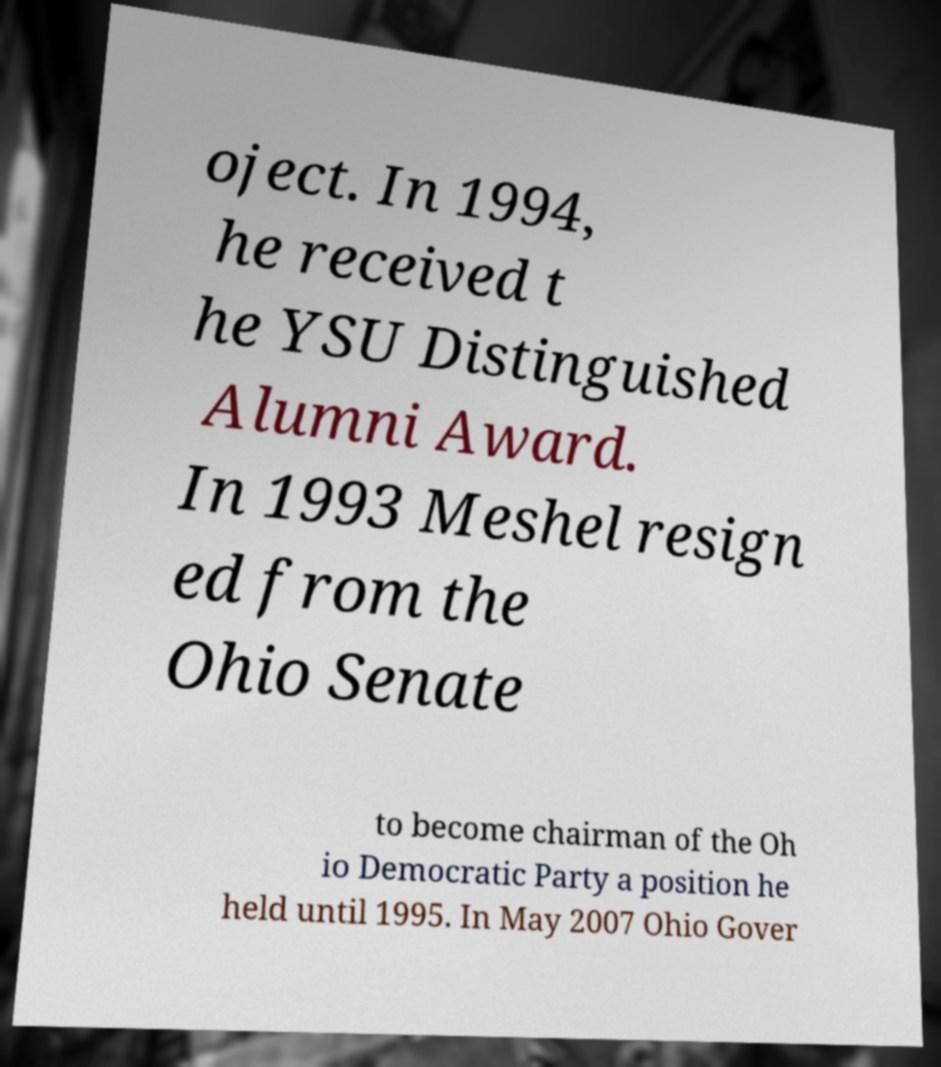Can you accurately transcribe the text from the provided image for me? oject. In 1994, he received t he YSU Distinguished Alumni Award. In 1993 Meshel resign ed from the Ohio Senate to become chairman of the Oh io Democratic Party a position he held until 1995. In May 2007 Ohio Gover 